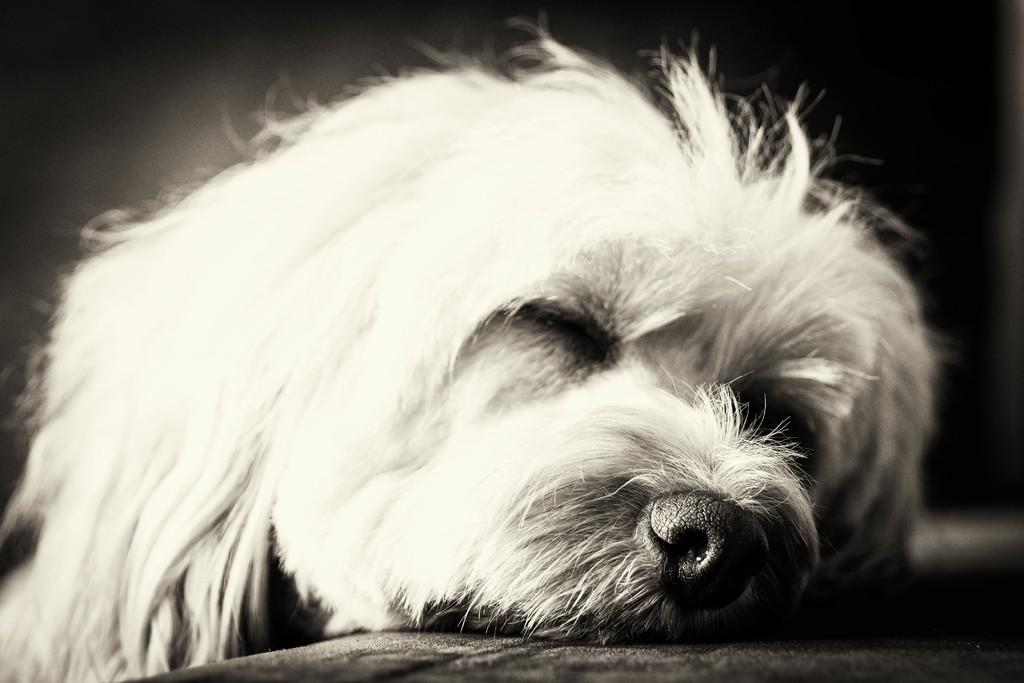What is the color scheme of the image? The image is black and white. What type of animal can be seen in the image? There is a dog in the image. What is the surface visible at the bottom of the image? The surface at the bottom of the image is not specified, but it is visible. What type of pancake is being served with humor in the image? There is no pancake or humor present in the image; it features a black and white image of a dog. 